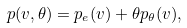<formula> <loc_0><loc_0><loc_500><loc_500>p ( v , \theta ) = p _ { e } ( v ) + \theta p _ { \theta } ( v ) ,</formula> 